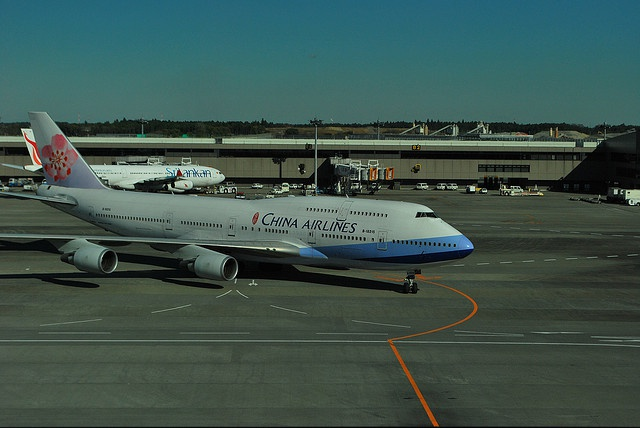Describe the objects in this image and their specific colors. I can see airplane in teal, black, gray, and darkgray tones, airplane in teal, lightgray, darkgray, lightblue, and beige tones, car in teal, black, gray, and darkgray tones, car in teal, black, darkgray, and gray tones, and car in teal, black, maroon, and gray tones in this image. 